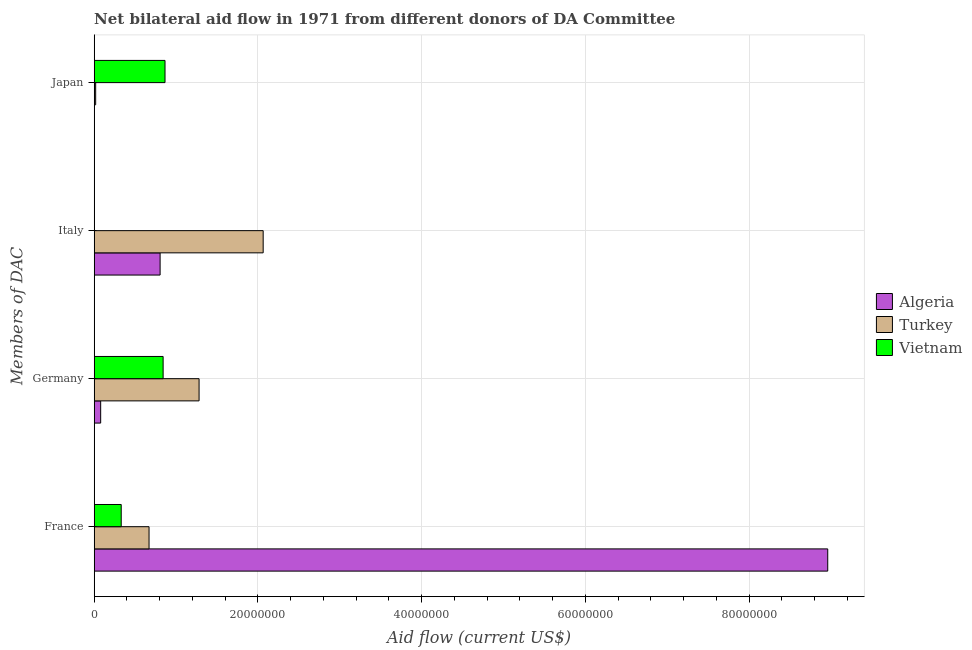Are the number of bars per tick equal to the number of legend labels?
Offer a very short reply. Yes. Are the number of bars on each tick of the Y-axis equal?
Your answer should be compact. Yes. How many bars are there on the 2nd tick from the top?
Offer a very short reply. 3. What is the label of the 1st group of bars from the top?
Your answer should be very brief. Japan. What is the amount of aid given by italy in Turkey?
Your response must be concise. 2.06e+07. Across all countries, what is the maximum amount of aid given by germany?
Provide a short and direct response. 1.28e+07. Across all countries, what is the minimum amount of aid given by france?
Your answer should be very brief. 3.30e+06. In which country was the amount of aid given by japan minimum?
Provide a succinct answer. Algeria. What is the total amount of aid given by italy in the graph?
Your answer should be compact. 2.87e+07. What is the difference between the amount of aid given by france in Turkey and that in Vietnam?
Your answer should be compact. 3.40e+06. What is the difference between the amount of aid given by france in Algeria and the amount of aid given by germany in Turkey?
Provide a short and direct response. 7.68e+07. What is the average amount of aid given by italy per country?
Make the answer very short. 9.57e+06. What is the difference between the amount of aid given by italy and amount of aid given by japan in Algeria?
Offer a terse response. 8.03e+06. What is the ratio of the amount of aid given by italy in Vietnam to that in Algeria?
Offer a very short reply. 0. Is the amount of aid given by italy in Vietnam less than that in Turkey?
Ensure brevity in your answer.  Yes. What is the difference between the highest and the second highest amount of aid given by japan?
Your response must be concise. 8.47e+06. What is the difference between the highest and the lowest amount of aid given by japan?
Offer a very short reply. 8.63e+06. In how many countries, is the amount of aid given by france greater than the average amount of aid given by france taken over all countries?
Offer a very short reply. 1. What does the 1st bar from the top in Italy represents?
Make the answer very short. Vietnam. What does the 1st bar from the bottom in Japan represents?
Make the answer very short. Algeria. Is it the case that in every country, the sum of the amount of aid given by france and amount of aid given by germany is greater than the amount of aid given by italy?
Give a very brief answer. No. How many bars are there?
Make the answer very short. 12. How many countries are there in the graph?
Offer a very short reply. 3. Are the values on the major ticks of X-axis written in scientific E-notation?
Offer a terse response. No. Does the graph contain any zero values?
Your answer should be very brief. No. Where does the legend appear in the graph?
Offer a very short reply. Center right. How are the legend labels stacked?
Give a very brief answer. Vertical. What is the title of the graph?
Offer a terse response. Net bilateral aid flow in 1971 from different donors of DA Committee. Does "South Asia" appear as one of the legend labels in the graph?
Your answer should be very brief. No. What is the label or title of the X-axis?
Offer a terse response. Aid flow (current US$). What is the label or title of the Y-axis?
Your answer should be very brief. Members of DAC. What is the Aid flow (current US$) in Algeria in France?
Offer a terse response. 8.96e+07. What is the Aid flow (current US$) of Turkey in France?
Offer a very short reply. 6.70e+06. What is the Aid flow (current US$) of Vietnam in France?
Your response must be concise. 3.30e+06. What is the Aid flow (current US$) of Algeria in Germany?
Offer a very short reply. 7.90e+05. What is the Aid flow (current US$) of Turkey in Germany?
Make the answer very short. 1.28e+07. What is the Aid flow (current US$) in Vietnam in Germany?
Keep it short and to the point. 8.42e+06. What is the Aid flow (current US$) in Algeria in Italy?
Offer a terse response. 8.05e+06. What is the Aid flow (current US$) of Turkey in Italy?
Offer a very short reply. 2.06e+07. What is the Aid flow (current US$) in Vietnam in Japan?
Ensure brevity in your answer.  8.65e+06. Across all Members of DAC, what is the maximum Aid flow (current US$) in Algeria?
Give a very brief answer. 8.96e+07. Across all Members of DAC, what is the maximum Aid flow (current US$) of Turkey?
Give a very brief answer. 2.06e+07. Across all Members of DAC, what is the maximum Aid flow (current US$) of Vietnam?
Your response must be concise. 8.65e+06. Across all Members of DAC, what is the minimum Aid flow (current US$) of Turkey?
Make the answer very short. 1.80e+05. Across all Members of DAC, what is the minimum Aid flow (current US$) in Vietnam?
Provide a succinct answer. 2.00e+04. What is the total Aid flow (current US$) in Algeria in the graph?
Offer a very short reply. 9.85e+07. What is the total Aid flow (current US$) of Turkey in the graph?
Your answer should be very brief. 4.03e+07. What is the total Aid flow (current US$) in Vietnam in the graph?
Keep it short and to the point. 2.04e+07. What is the difference between the Aid flow (current US$) in Algeria in France and that in Germany?
Ensure brevity in your answer.  8.88e+07. What is the difference between the Aid flow (current US$) of Turkey in France and that in Germany?
Provide a succinct answer. -6.11e+06. What is the difference between the Aid flow (current US$) in Vietnam in France and that in Germany?
Offer a very short reply. -5.12e+06. What is the difference between the Aid flow (current US$) in Algeria in France and that in Italy?
Offer a very short reply. 8.16e+07. What is the difference between the Aid flow (current US$) of Turkey in France and that in Italy?
Offer a very short reply. -1.39e+07. What is the difference between the Aid flow (current US$) in Vietnam in France and that in Italy?
Give a very brief answer. 3.28e+06. What is the difference between the Aid flow (current US$) of Algeria in France and that in Japan?
Keep it short and to the point. 8.96e+07. What is the difference between the Aid flow (current US$) of Turkey in France and that in Japan?
Ensure brevity in your answer.  6.52e+06. What is the difference between the Aid flow (current US$) in Vietnam in France and that in Japan?
Your response must be concise. -5.35e+06. What is the difference between the Aid flow (current US$) of Algeria in Germany and that in Italy?
Ensure brevity in your answer.  -7.26e+06. What is the difference between the Aid flow (current US$) in Turkey in Germany and that in Italy?
Provide a succinct answer. -7.83e+06. What is the difference between the Aid flow (current US$) in Vietnam in Germany and that in Italy?
Ensure brevity in your answer.  8.40e+06. What is the difference between the Aid flow (current US$) of Algeria in Germany and that in Japan?
Give a very brief answer. 7.70e+05. What is the difference between the Aid flow (current US$) of Turkey in Germany and that in Japan?
Make the answer very short. 1.26e+07. What is the difference between the Aid flow (current US$) in Vietnam in Germany and that in Japan?
Your answer should be compact. -2.30e+05. What is the difference between the Aid flow (current US$) of Algeria in Italy and that in Japan?
Offer a terse response. 8.03e+06. What is the difference between the Aid flow (current US$) of Turkey in Italy and that in Japan?
Offer a very short reply. 2.05e+07. What is the difference between the Aid flow (current US$) of Vietnam in Italy and that in Japan?
Your answer should be compact. -8.63e+06. What is the difference between the Aid flow (current US$) of Algeria in France and the Aid flow (current US$) of Turkey in Germany?
Provide a short and direct response. 7.68e+07. What is the difference between the Aid flow (current US$) of Algeria in France and the Aid flow (current US$) of Vietnam in Germany?
Offer a terse response. 8.12e+07. What is the difference between the Aid flow (current US$) of Turkey in France and the Aid flow (current US$) of Vietnam in Germany?
Your response must be concise. -1.72e+06. What is the difference between the Aid flow (current US$) of Algeria in France and the Aid flow (current US$) of Turkey in Italy?
Keep it short and to the point. 6.90e+07. What is the difference between the Aid flow (current US$) in Algeria in France and the Aid flow (current US$) in Vietnam in Italy?
Offer a terse response. 8.96e+07. What is the difference between the Aid flow (current US$) of Turkey in France and the Aid flow (current US$) of Vietnam in Italy?
Offer a very short reply. 6.68e+06. What is the difference between the Aid flow (current US$) in Algeria in France and the Aid flow (current US$) in Turkey in Japan?
Your response must be concise. 8.94e+07. What is the difference between the Aid flow (current US$) in Algeria in France and the Aid flow (current US$) in Vietnam in Japan?
Make the answer very short. 8.10e+07. What is the difference between the Aid flow (current US$) in Turkey in France and the Aid flow (current US$) in Vietnam in Japan?
Make the answer very short. -1.95e+06. What is the difference between the Aid flow (current US$) in Algeria in Germany and the Aid flow (current US$) in Turkey in Italy?
Offer a very short reply. -1.98e+07. What is the difference between the Aid flow (current US$) in Algeria in Germany and the Aid flow (current US$) in Vietnam in Italy?
Give a very brief answer. 7.70e+05. What is the difference between the Aid flow (current US$) of Turkey in Germany and the Aid flow (current US$) of Vietnam in Italy?
Provide a short and direct response. 1.28e+07. What is the difference between the Aid flow (current US$) in Algeria in Germany and the Aid flow (current US$) in Vietnam in Japan?
Your answer should be compact. -7.86e+06. What is the difference between the Aid flow (current US$) in Turkey in Germany and the Aid flow (current US$) in Vietnam in Japan?
Offer a very short reply. 4.16e+06. What is the difference between the Aid flow (current US$) of Algeria in Italy and the Aid flow (current US$) of Turkey in Japan?
Your answer should be very brief. 7.87e+06. What is the difference between the Aid flow (current US$) in Algeria in Italy and the Aid flow (current US$) in Vietnam in Japan?
Give a very brief answer. -6.00e+05. What is the difference between the Aid flow (current US$) of Turkey in Italy and the Aid flow (current US$) of Vietnam in Japan?
Keep it short and to the point. 1.20e+07. What is the average Aid flow (current US$) in Algeria per Members of DAC?
Offer a very short reply. 2.46e+07. What is the average Aid flow (current US$) of Turkey per Members of DAC?
Your response must be concise. 1.01e+07. What is the average Aid flow (current US$) of Vietnam per Members of DAC?
Offer a terse response. 5.10e+06. What is the difference between the Aid flow (current US$) in Algeria and Aid flow (current US$) in Turkey in France?
Offer a very short reply. 8.29e+07. What is the difference between the Aid flow (current US$) in Algeria and Aid flow (current US$) in Vietnam in France?
Your response must be concise. 8.63e+07. What is the difference between the Aid flow (current US$) in Turkey and Aid flow (current US$) in Vietnam in France?
Provide a succinct answer. 3.40e+06. What is the difference between the Aid flow (current US$) of Algeria and Aid flow (current US$) of Turkey in Germany?
Your answer should be very brief. -1.20e+07. What is the difference between the Aid flow (current US$) in Algeria and Aid flow (current US$) in Vietnam in Germany?
Your answer should be very brief. -7.63e+06. What is the difference between the Aid flow (current US$) of Turkey and Aid flow (current US$) of Vietnam in Germany?
Give a very brief answer. 4.39e+06. What is the difference between the Aid flow (current US$) in Algeria and Aid flow (current US$) in Turkey in Italy?
Your answer should be very brief. -1.26e+07. What is the difference between the Aid flow (current US$) of Algeria and Aid flow (current US$) of Vietnam in Italy?
Give a very brief answer. 8.03e+06. What is the difference between the Aid flow (current US$) of Turkey and Aid flow (current US$) of Vietnam in Italy?
Keep it short and to the point. 2.06e+07. What is the difference between the Aid flow (current US$) in Algeria and Aid flow (current US$) in Vietnam in Japan?
Keep it short and to the point. -8.63e+06. What is the difference between the Aid flow (current US$) of Turkey and Aid flow (current US$) of Vietnam in Japan?
Give a very brief answer. -8.47e+06. What is the ratio of the Aid flow (current US$) of Algeria in France to that in Germany?
Your answer should be very brief. 113.42. What is the ratio of the Aid flow (current US$) of Turkey in France to that in Germany?
Offer a very short reply. 0.52. What is the ratio of the Aid flow (current US$) in Vietnam in France to that in Germany?
Provide a short and direct response. 0.39. What is the ratio of the Aid flow (current US$) of Algeria in France to that in Italy?
Your answer should be compact. 11.13. What is the ratio of the Aid flow (current US$) of Turkey in France to that in Italy?
Offer a very short reply. 0.32. What is the ratio of the Aid flow (current US$) in Vietnam in France to that in Italy?
Your response must be concise. 165. What is the ratio of the Aid flow (current US$) of Algeria in France to that in Japan?
Provide a succinct answer. 4480. What is the ratio of the Aid flow (current US$) in Turkey in France to that in Japan?
Provide a short and direct response. 37.22. What is the ratio of the Aid flow (current US$) in Vietnam in France to that in Japan?
Give a very brief answer. 0.38. What is the ratio of the Aid flow (current US$) of Algeria in Germany to that in Italy?
Keep it short and to the point. 0.1. What is the ratio of the Aid flow (current US$) of Turkey in Germany to that in Italy?
Make the answer very short. 0.62. What is the ratio of the Aid flow (current US$) in Vietnam in Germany to that in Italy?
Your answer should be compact. 421. What is the ratio of the Aid flow (current US$) of Algeria in Germany to that in Japan?
Offer a terse response. 39.5. What is the ratio of the Aid flow (current US$) of Turkey in Germany to that in Japan?
Offer a terse response. 71.17. What is the ratio of the Aid flow (current US$) of Vietnam in Germany to that in Japan?
Provide a succinct answer. 0.97. What is the ratio of the Aid flow (current US$) in Algeria in Italy to that in Japan?
Your response must be concise. 402.5. What is the ratio of the Aid flow (current US$) in Turkey in Italy to that in Japan?
Your answer should be compact. 114.67. What is the ratio of the Aid flow (current US$) in Vietnam in Italy to that in Japan?
Provide a succinct answer. 0. What is the difference between the highest and the second highest Aid flow (current US$) of Algeria?
Ensure brevity in your answer.  8.16e+07. What is the difference between the highest and the second highest Aid flow (current US$) of Turkey?
Give a very brief answer. 7.83e+06. What is the difference between the highest and the lowest Aid flow (current US$) of Algeria?
Offer a very short reply. 8.96e+07. What is the difference between the highest and the lowest Aid flow (current US$) in Turkey?
Ensure brevity in your answer.  2.05e+07. What is the difference between the highest and the lowest Aid flow (current US$) of Vietnam?
Give a very brief answer. 8.63e+06. 